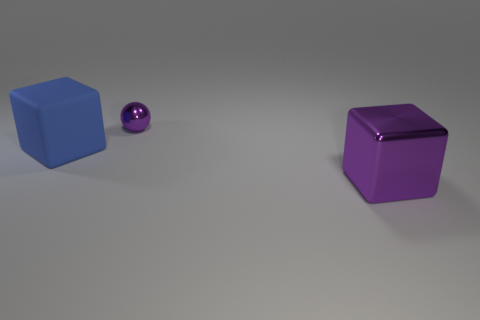Subtract all yellow spheres. Subtract all green cylinders. How many spheres are left? 1 Add 2 big brown cylinders. How many objects exist? 5 Subtract all balls. How many objects are left? 2 Subtract 0 blue spheres. How many objects are left? 3 Subtract all large cyan blocks. Subtract all tiny things. How many objects are left? 2 Add 2 large shiny blocks. How many large shiny blocks are left? 3 Add 1 purple cubes. How many purple cubes exist? 2 